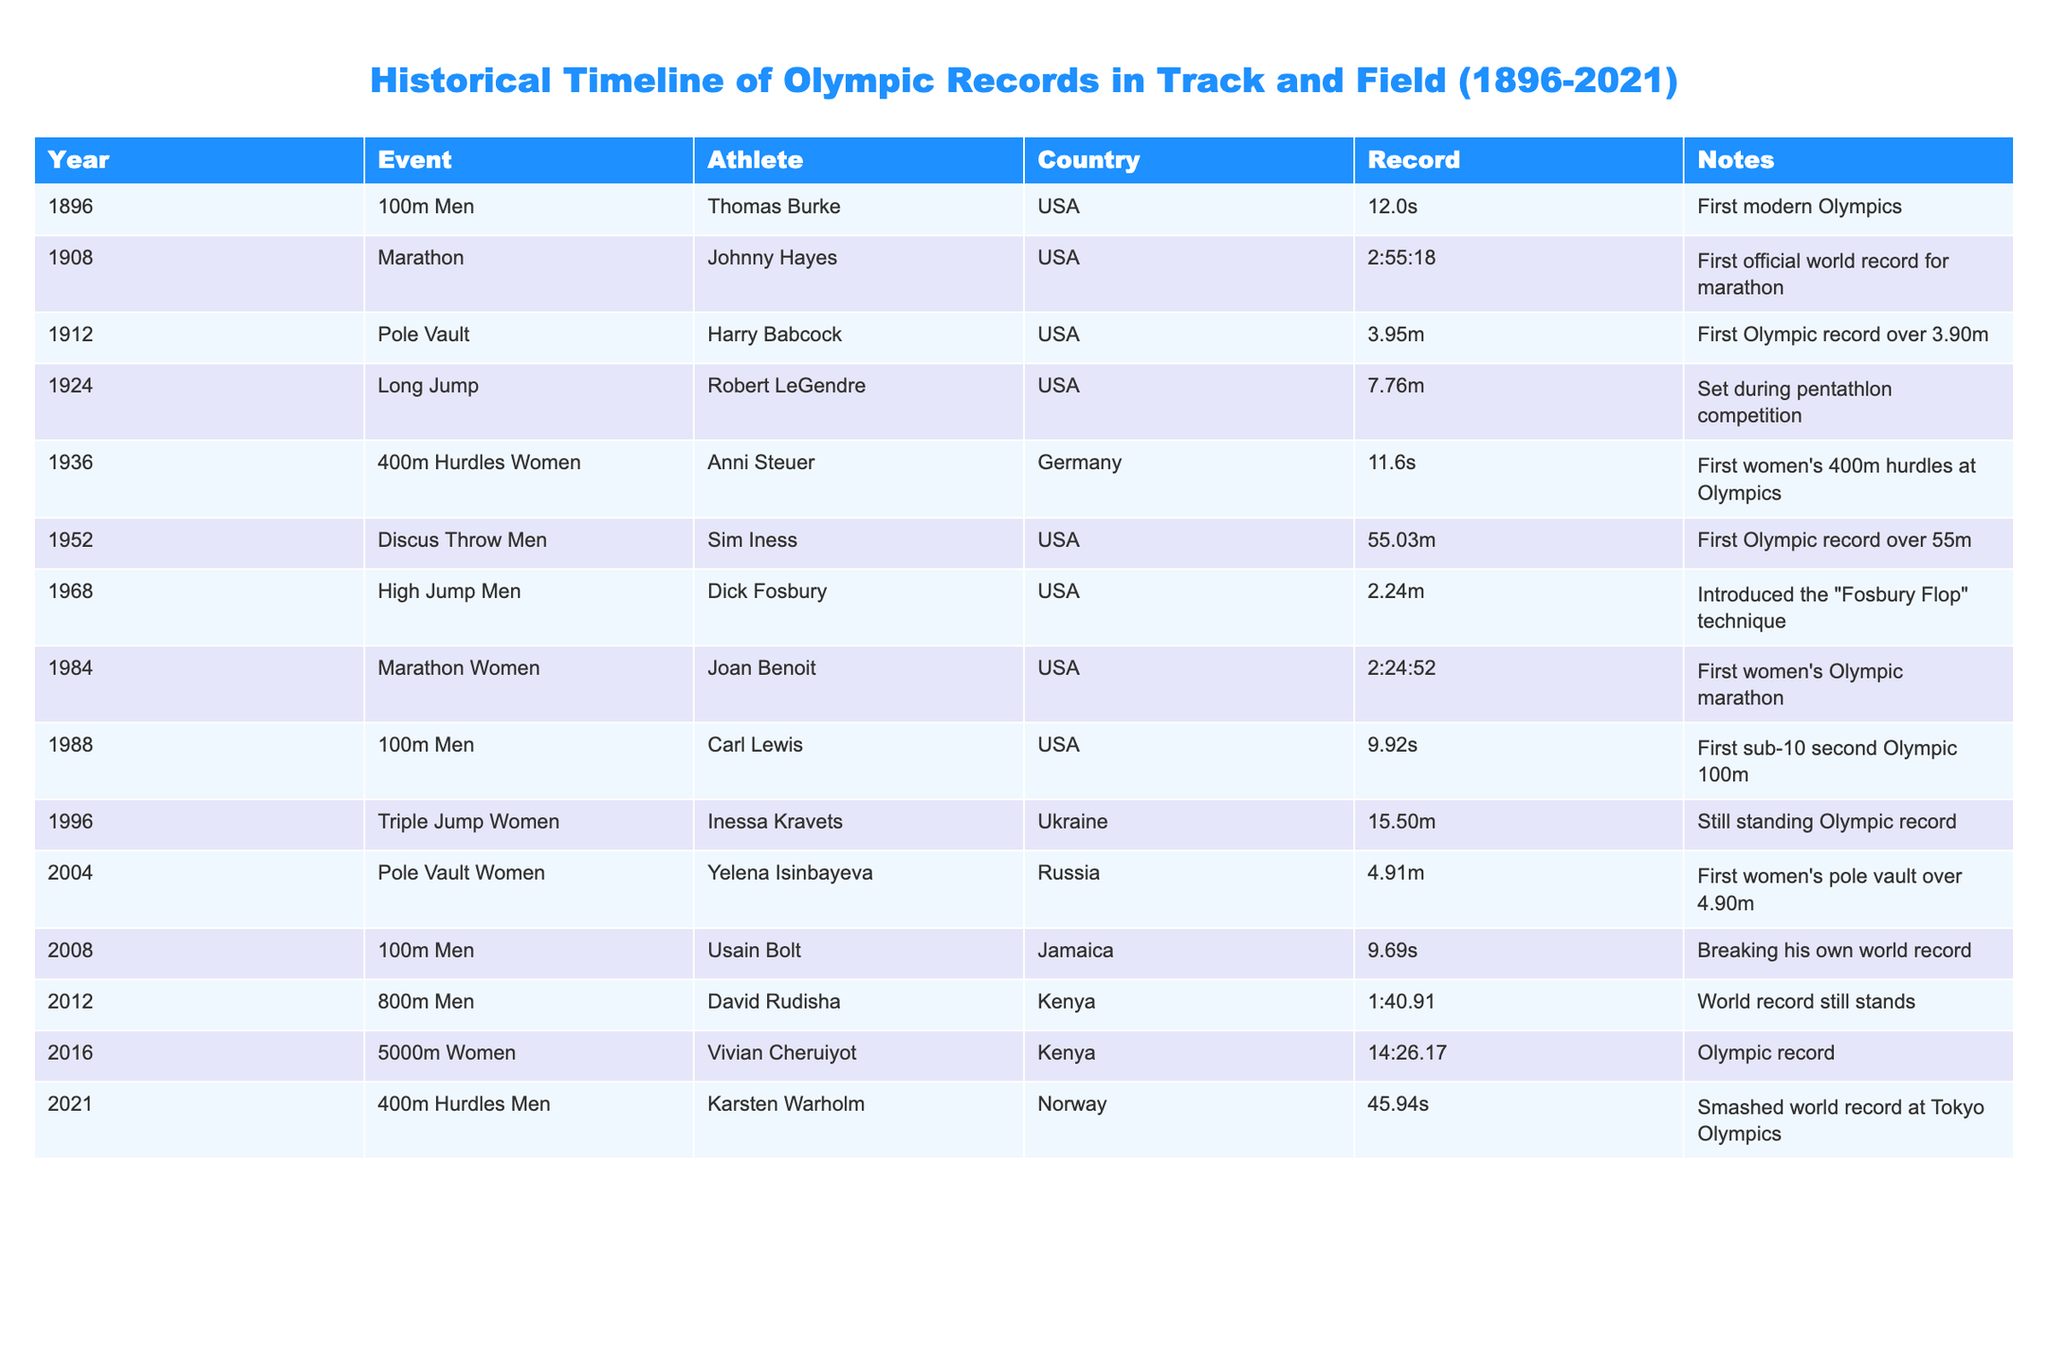What year was the first women's Olympic marathon held? According to the table, the first women's Olympic marathon was in 1984, as noted in the row for the event 'Marathon Women' where Joan Benoit set a record.
Answer: 1984 Who broke the record for the 100m Men's event in 2008? The table indicates that Usain Bolt from Jamaica broke the record for the 100m Men's event in 2008.
Answer: Usain Bolt What is the longest Olympic record in the table for the women's triple jump? From the table, Inessa Kravets set the long-standing Olympic record for the women's triple jump at 15.50m in 1996. There are no other records in the table for this event, making it the longest.
Answer: 15.50m Was there a record-breaking event for women's 400m hurdles prior to 1936? The table shows that the first women's 400m hurdles event was held in 1936, as denoted in the record for Anni Steuer. Therefore, there were no events prior to that.
Answer: No What was the difference in time between the first men's 100m record in 1896 and the 2008 record? The first men's 100m record set by Thomas Burke in 1896 was 12.0 seconds, while Usain Bolt's record in 2008 was 9.69 seconds. Subtracting gives 12.0 - 9.69 = 2.31 seconds.
Answer: 2.31 seconds How many Olympic records were broken in the 2000s? By reviewing the table, there were three events in the 2000s that had record entries: the 100m Men in 2008, the Pole Vault Women in 2004, and the Triple Jump Women in 1996 (although the latter is not in the 2000s, we can focus on the two in the decade). Thus, the total is 2 records broken in the 2000s.
Answer: 2 Which athlete introduced a new technique in the high jump? The table indicates that Dick Fosbury used the "Fosbury Flop" technique in the high jump event in 1968, marking a significant innovation in the sport.
Answer: Dick Fosbury What is the trend seen regarding women's events from 1896 to 2021 in the table? Observing the table, we see a gradual inclusion of women's events, starting officially with women's records from 1936. As more events were introduced, records continued to be established, culminating in a notable record in the 400m hurdles in 2021, indicating an increasing participation and recognition of female athletes in the Olympics.
Answer: Increasing participation and recognition How many countries were represented among the record-breaking athletes? By analyzing the table, we can identify the unique countries associated with the athletes: USA, Germany, Ukraine, Russia, Jamaica, Kenya, and Norway. This yields a total of 7 different countries.
Answer: 7 